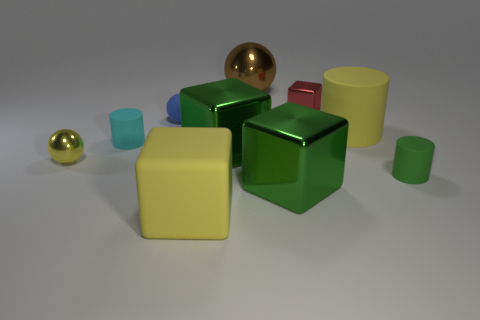What color is the big cube on the left side of the green metal block that is on the left side of the big green cube that is in front of the yellow metal object?
Your answer should be very brief. Yellow. What color is the small cylinder to the right of the big green cube that is in front of the tiny green matte object?
Ensure brevity in your answer.  Green. Are there more cyan matte things in front of the big cylinder than small cyan cylinders that are behind the red object?
Give a very brief answer. Yes. Is the large green thing that is on the right side of the brown shiny ball made of the same material as the cylinder that is to the left of the matte ball?
Keep it short and to the point. No. There is a large cylinder; are there any tiny objects on the right side of it?
Your response must be concise. Yes. How many green things are either small things or big metallic things?
Ensure brevity in your answer.  3. Are the tiny blue ball and the large yellow object to the right of the tiny red block made of the same material?
Offer a very short reply. Yes. There is a yellow thing that is the same shape as the tiny cyan thing; what size is it?
Make the answer very short. Large. What is the material of the green cylinder?
Your response must be concise. Rubber. There is a tiny blue sphere to the left of the yellow thing in front of the small cylinder that is to the right of the small matte sphere; what is it made of?
Make the answer very short. Rubber. 